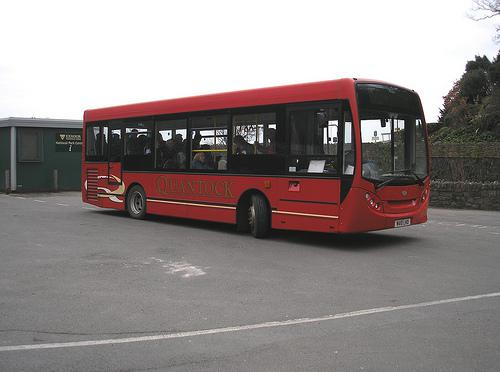Question: who is on the bus?
Choices:
A. Kids.
B. Clowns.
C. People.
D. Preachers.
Answer with the letter. Answer: C Question: what are the people on?
Choices:
A. A table.
B. A hill.
C. A stage.
D. The bus.
Answer with the letter. Answer: D 